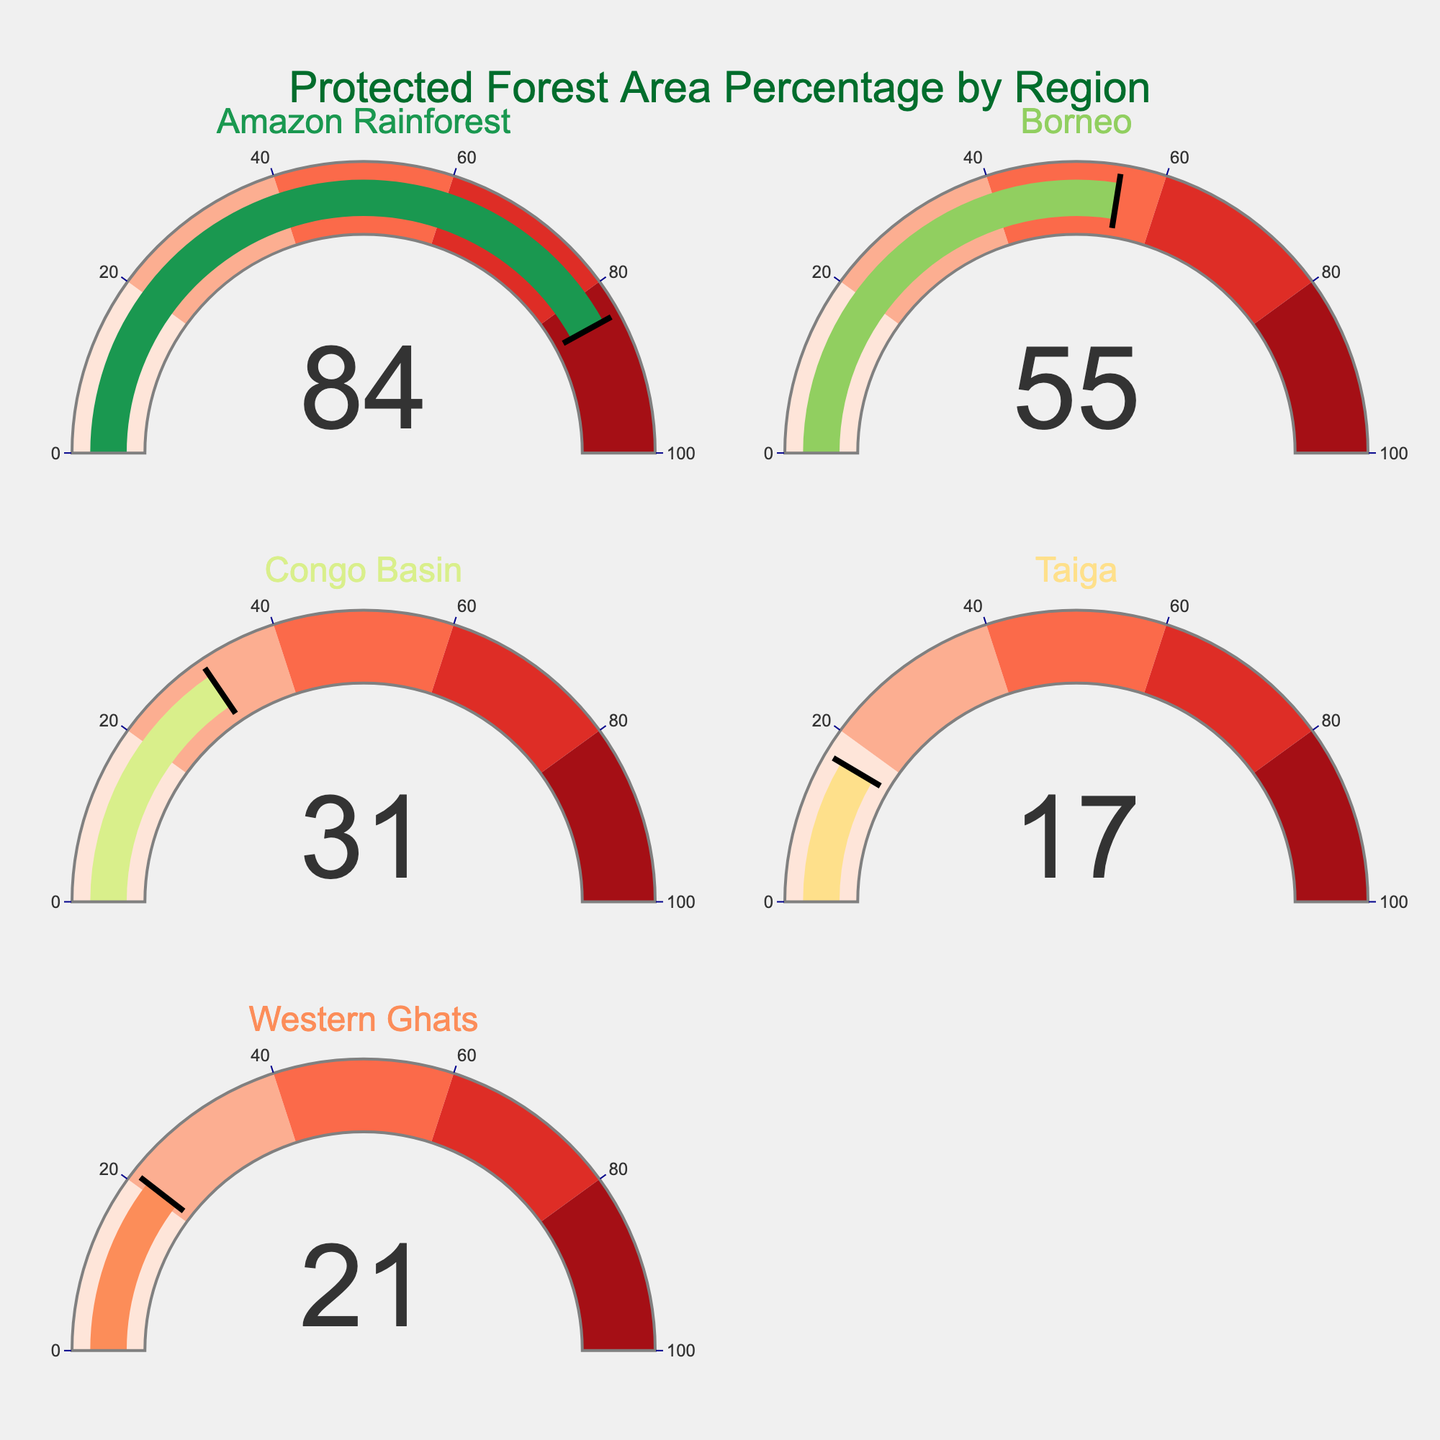How many regions are represented in the figure? Count the number of different gauge charts, each representing a region. There are 5 separate gauge charts, hence 5 regions are represented.
Answer: 5 Which region has the highest percentage of protected forest area? Look at the values on each gauge chart. The Amazon Rainforest has the highest value displayed, which is 84%.
Answer: Amazon Rainforest What is the combined percentage of protected forest areas for Borneo and Congo Basin? Add the percentages for Borneo (55%) and Congo Basin (31%). 55 + 31 = 86
Answer: 86 How much greater is the protected forest area percentage in the Amazon Rainforest compared to the Taiga? Subtract the percentage of the Taiga (17%) from the percentage of the Amazon Rainforest (84%). 84 - 17 = 67
Answer: 67 Which region has the lowest percentage of protected forest area? Identify the smallest value on the gauge charts. The Taiga has the lowest percentage at 17%.
Answer: Taiga On average, what is the percentage of protected forest area across all regions? Calculate the average by summing up all percentages and dividing by the number of regions: (84 + 55 + 31 + 17 + 21) / 5 = 208 / 5 = 41.6
Answer: 41.6 By what percentage is the protected forest area in the Western Ghats less than the protected forest area in Borneo? Subtract Western Ghats' percentage (21%) from Borneo's percentage (55%): 55 - 21 = 34
Answer: 34 If the Congo Basin's protected forest area were to increase by 10%, what would its new percentage be? Add 10% to the current Congo Basin's percentage (31%): 31 + 10 = 41
Answer: 41 Which regions have more than 50% of their forest area protected? Identify the regions with protected forest area percentages greater than 50. Both Amazon Rainforest (84%) and Borneo (55%) meet this criterion.
Answer: Amazon Rainforest, Borneo 